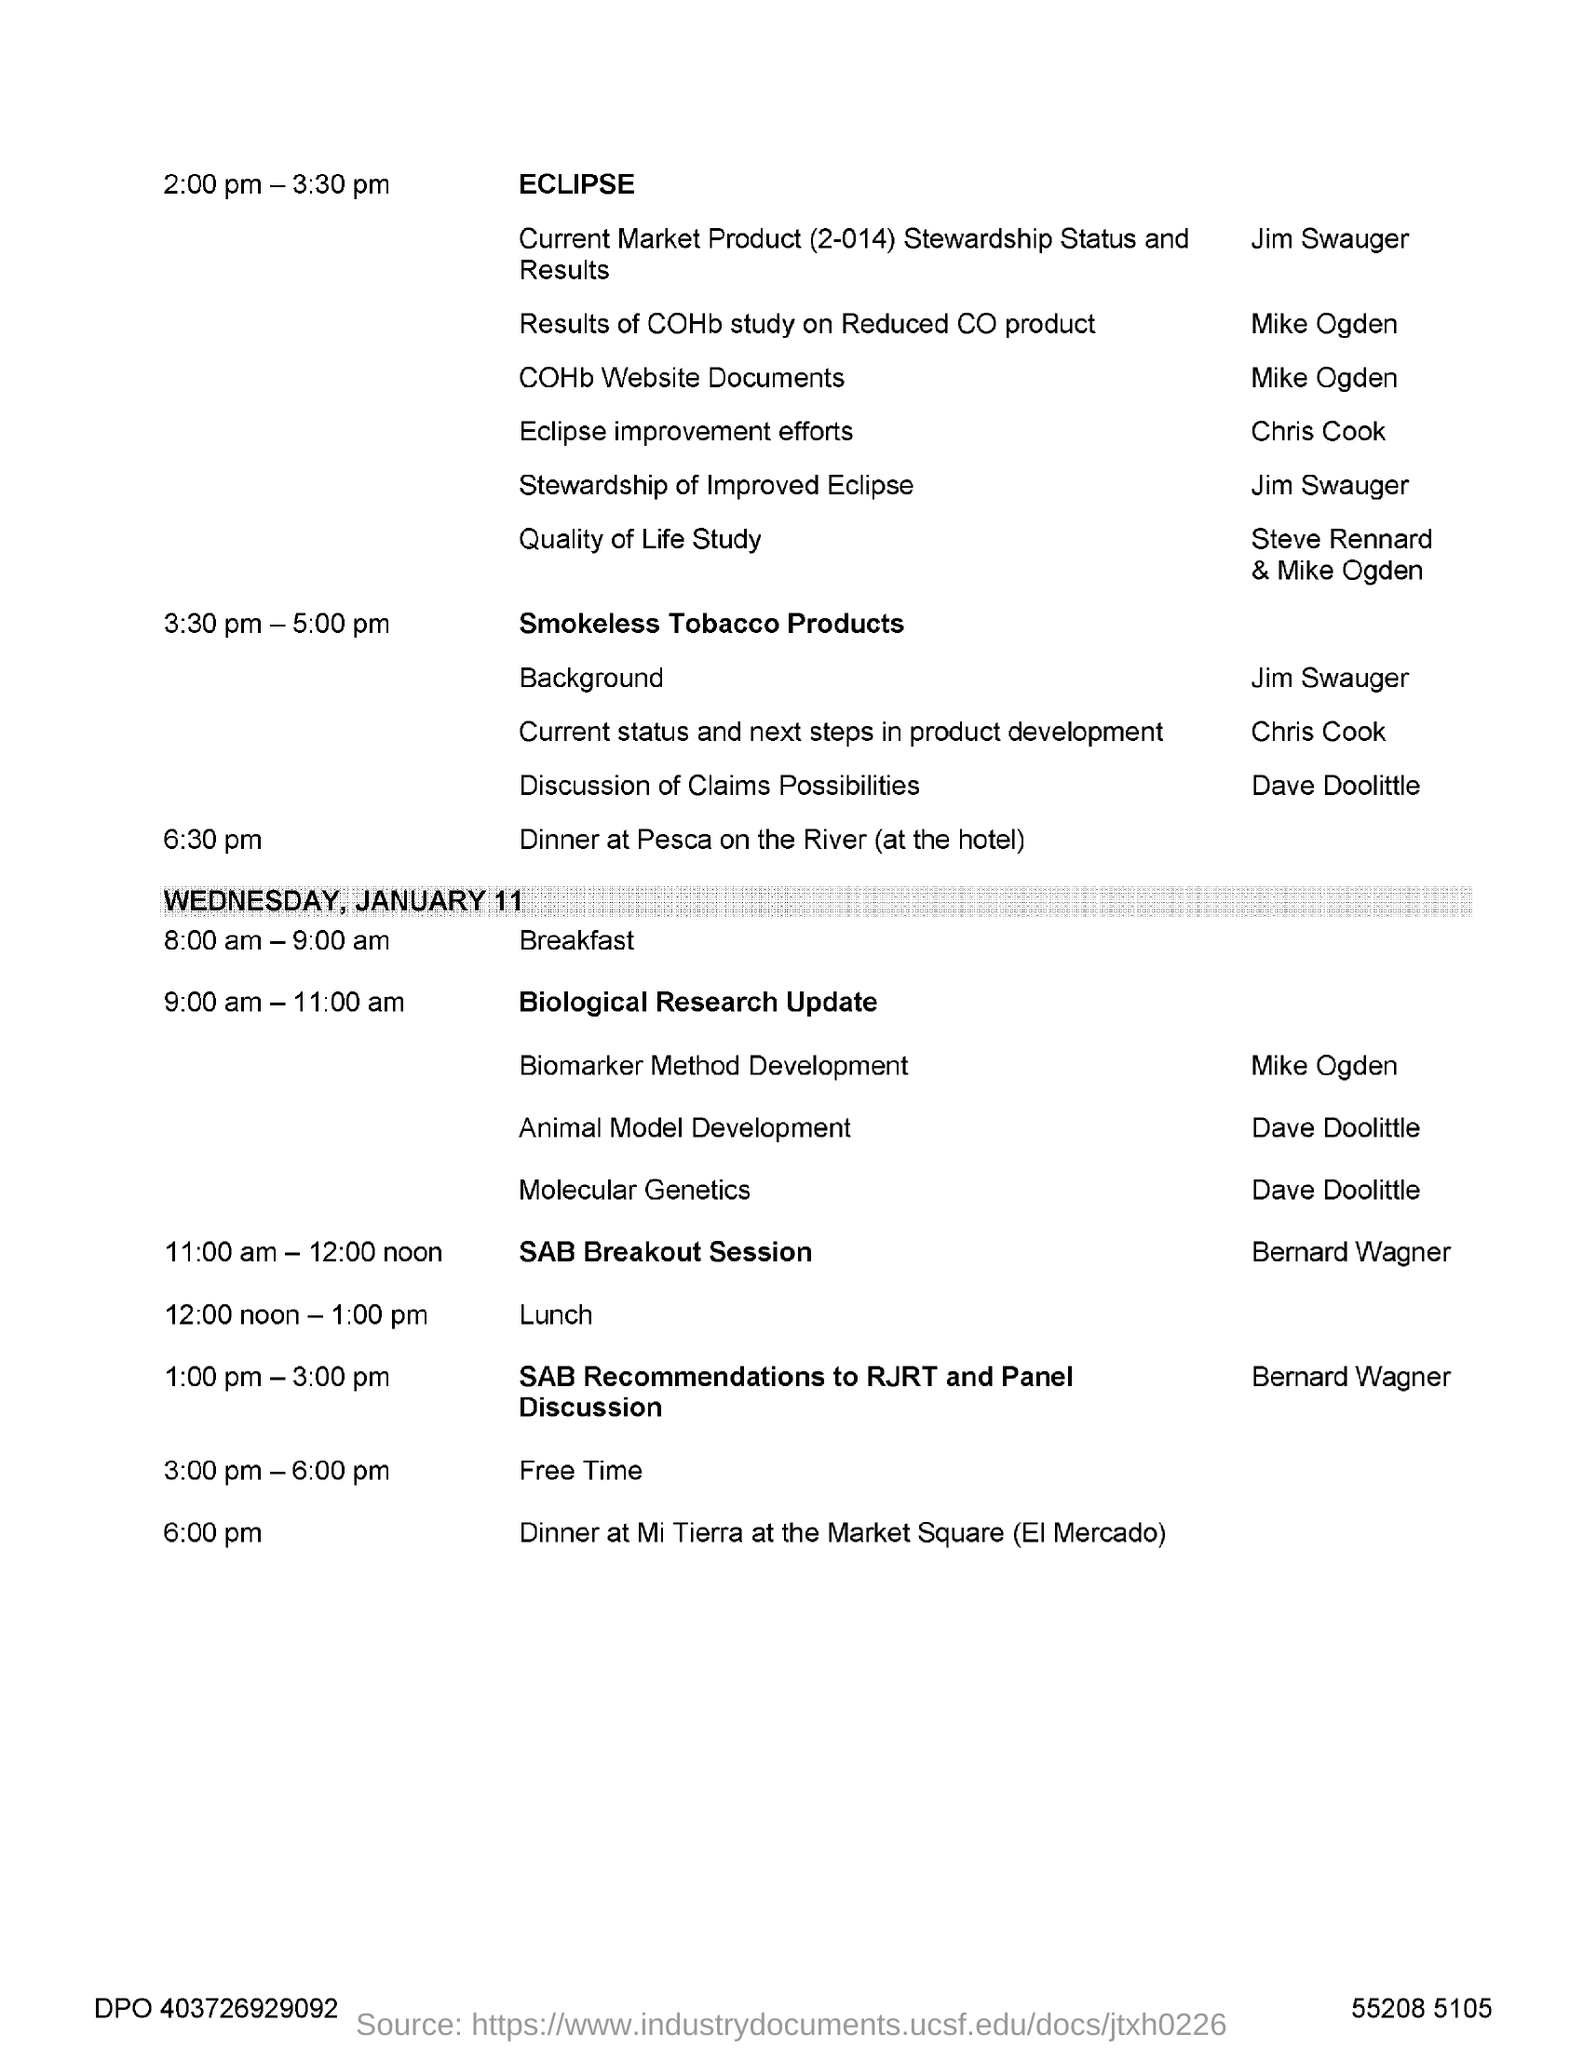Point out several critical features in this image. On Wednesday, January 11, the lunch is scheduled to begin at 12:00 noon and end at 1:00 pm. Dinner at Pesca on the River is scheduled for 6:30 pm. 